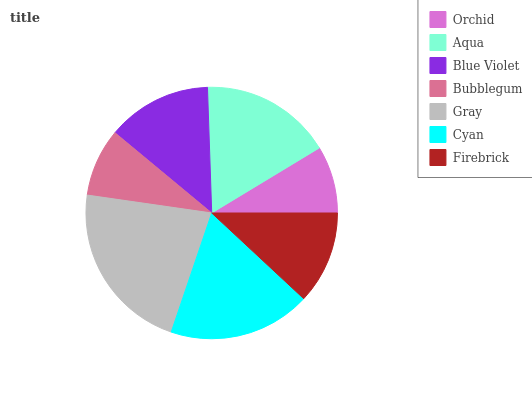Is Orchid the minimum?
Answer yes or no. Yes. Is Gray the maximum?
Answer yes or no. Yes. Is Aqua the minimum?
Answer yes or no. No. Is Aqua the maximum?
Answer yes or no. No. Is Aqua greater than Orchid?
Answer yes or no. Yes. Is Orchid less than Aqua?
Answer yes or no. Yes. Is Orchid greater than Aqua?
Answer yes or no. No. Is Aqua less than Orchid?
Answer yes or no. No. Is Blue Violet the high median?
Answer yes or no. Yes. Is Blue Violet the low median?
Answer yes or no. Yes. Is Aqua the high median?
Answer yes or no. No. Is Bubblegum the low median?
Answer yes or no. No. 